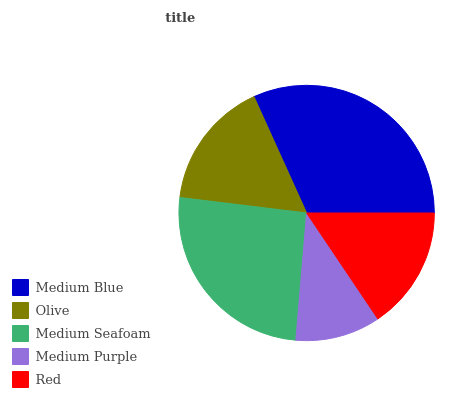Is Medium Purple the minimum?
Answer yes or no. Yes. Is Medium Blue the maximum?
Answer yes or no. Yes. Is Olive the minimum?
Answer yes or no. No. Is Olive the maximum?
Answer yes or no. No. Is Medium Blue greater than Olive?
Answer yes or no. Yes. Is Olive less than Medium Blue?
Answer yes or no. Yes. Is Olive greater than Medium Blue?
Answer yes or no. No. Is Medium Blue less than Olive?
Answer yes or no. No. Is Olive the high median?
Answer yes or no. Yes. Is Olive the low median?
Answer yes or no. Yes. Is Medium Purple the high median?
Answer yes or no. No. Is Medium Blue the low median?
Answer yes or no. No. 